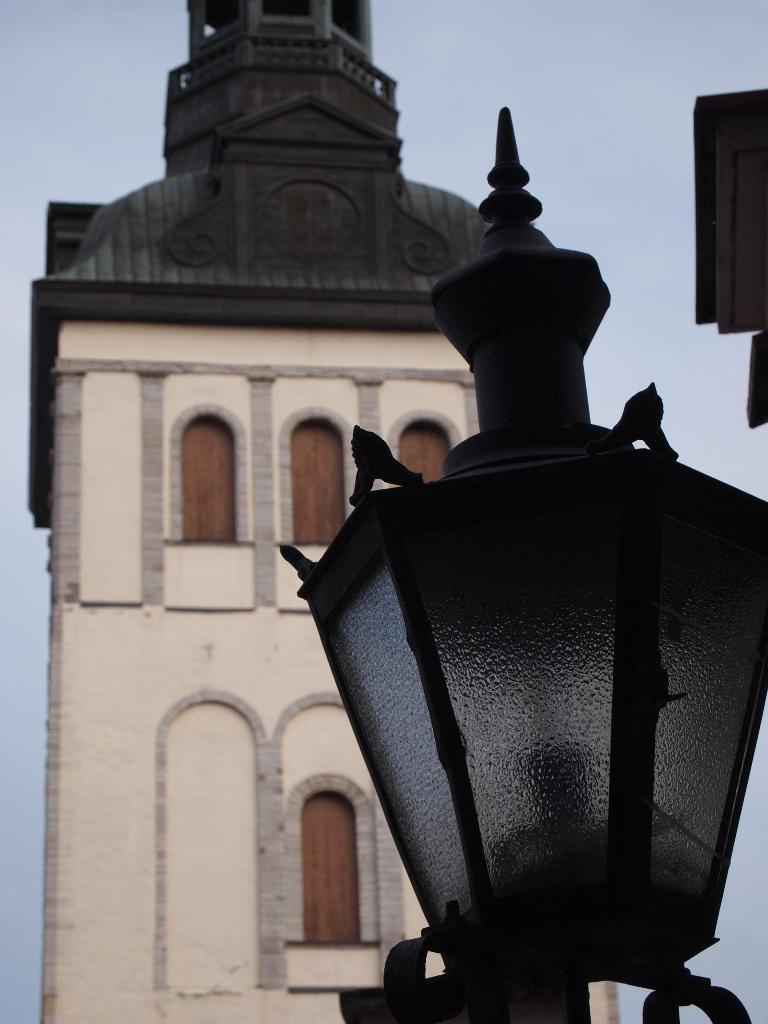What object is present on the right side of the image? There is a lamp fixed to a pole on the right side of the image. What is the lamp attached to? The lamp is fixed to a pole. What can be seen in the background of the image? There is a building and the sky visible in the background of the image. How many eyes can be seen on the lamp in the image? There are no eyes present on the lamp in the image, as lamps do not have eyes. 